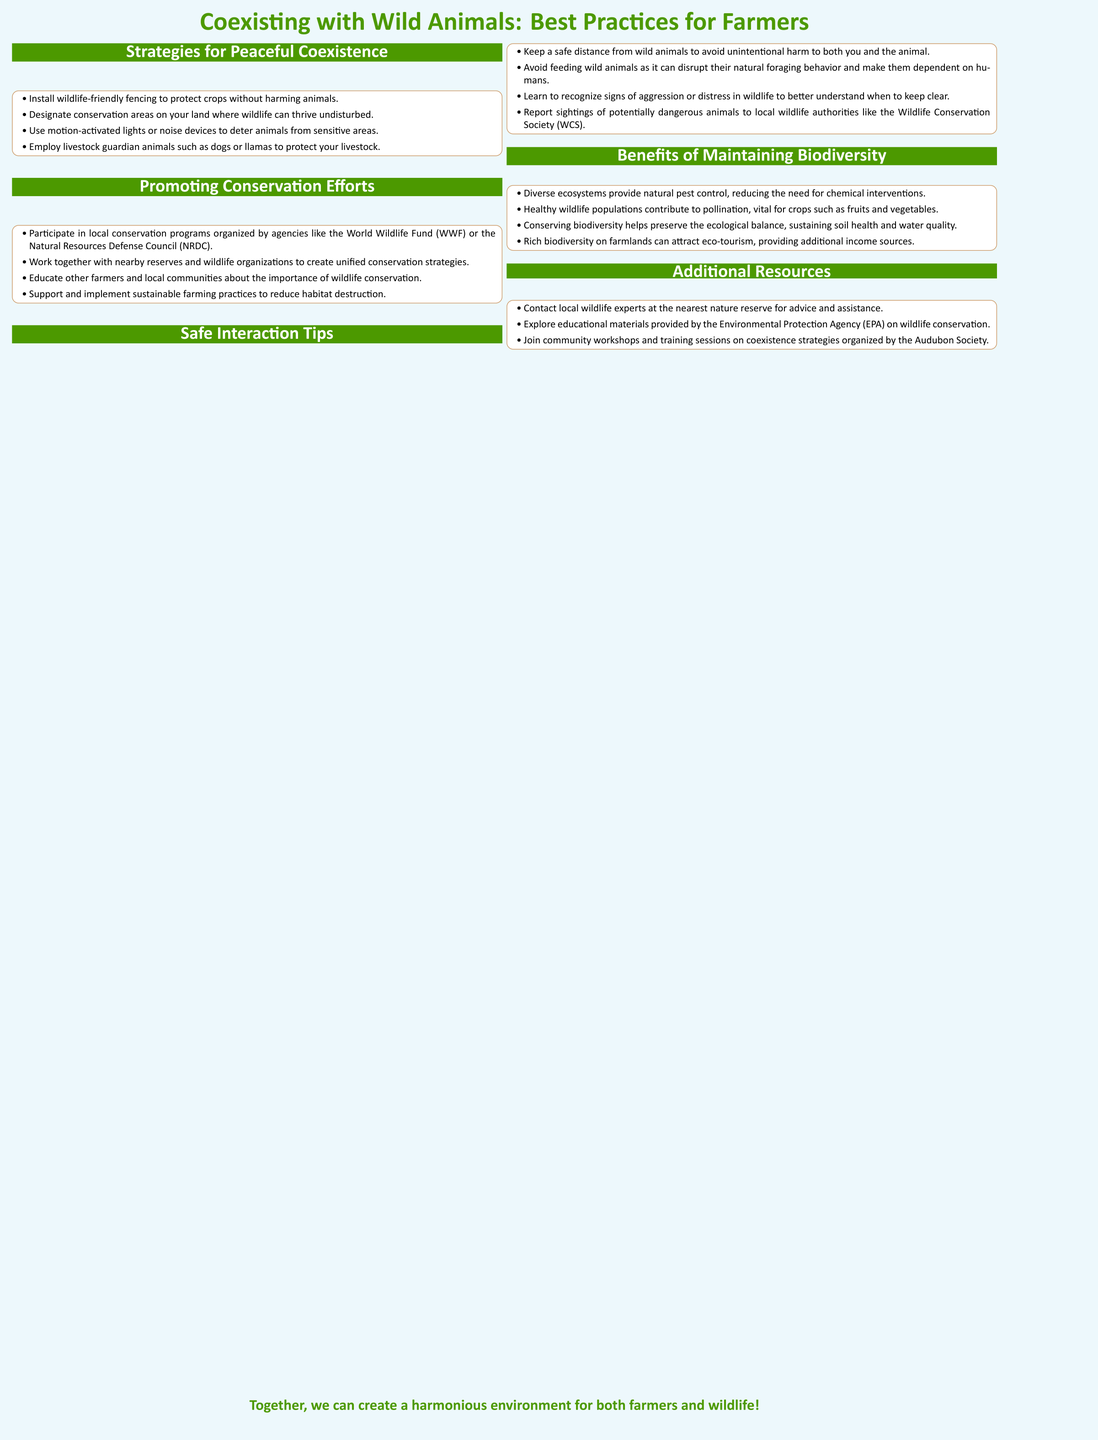What is one method to protect crops? The document lists several strategies for peaceful coexistence, one of which is to install wildlife-friendly fencing.
Answer: Install wildlife-friendly fencing Which organizations can farmers join for conservation efforts? The document mentions agencies like the World Wildlife Fund (WWF) and the Natural Resources Defense Council (NRDC) for participation in conservation programs.
Answer: World Wildlife Fund (WWF) What should you do if you see a potentially dangerous animal? The document advises reporting sightings of potentially dangerous animals to local wildlife authorities such as the Wildlife Conservation Society (WCS).
Answer: Report to Wildlife Conservation Society (WCS) Name one benefit of maintaining biodiversity. The document states various benefits, including that diverse ecosystems provide natural pest control, thus reducing the need for chemical interventions.
Answer: Natural pest control Which audience is this poster primarily intended for? The document is designed for farmers, as indicated by the title and content focused on their interactions with wildlife.
Answer: Farmers What type of animals can be used to safeguard livestock? The document mentions employing livestock guardian animals.
Answer: Guardian animals Identify one resource for farmers seeking assistance with wildlife interactions. The document suggests contacting local wildlife experts at the nearest nature reserve for advice.
Answer: Local wildlife experts How are farmers encouraged to educate their communities? The document states that farmers should educate other farmers and local communities about the importance of wildlife conservation.
Answer: Educate local communities 